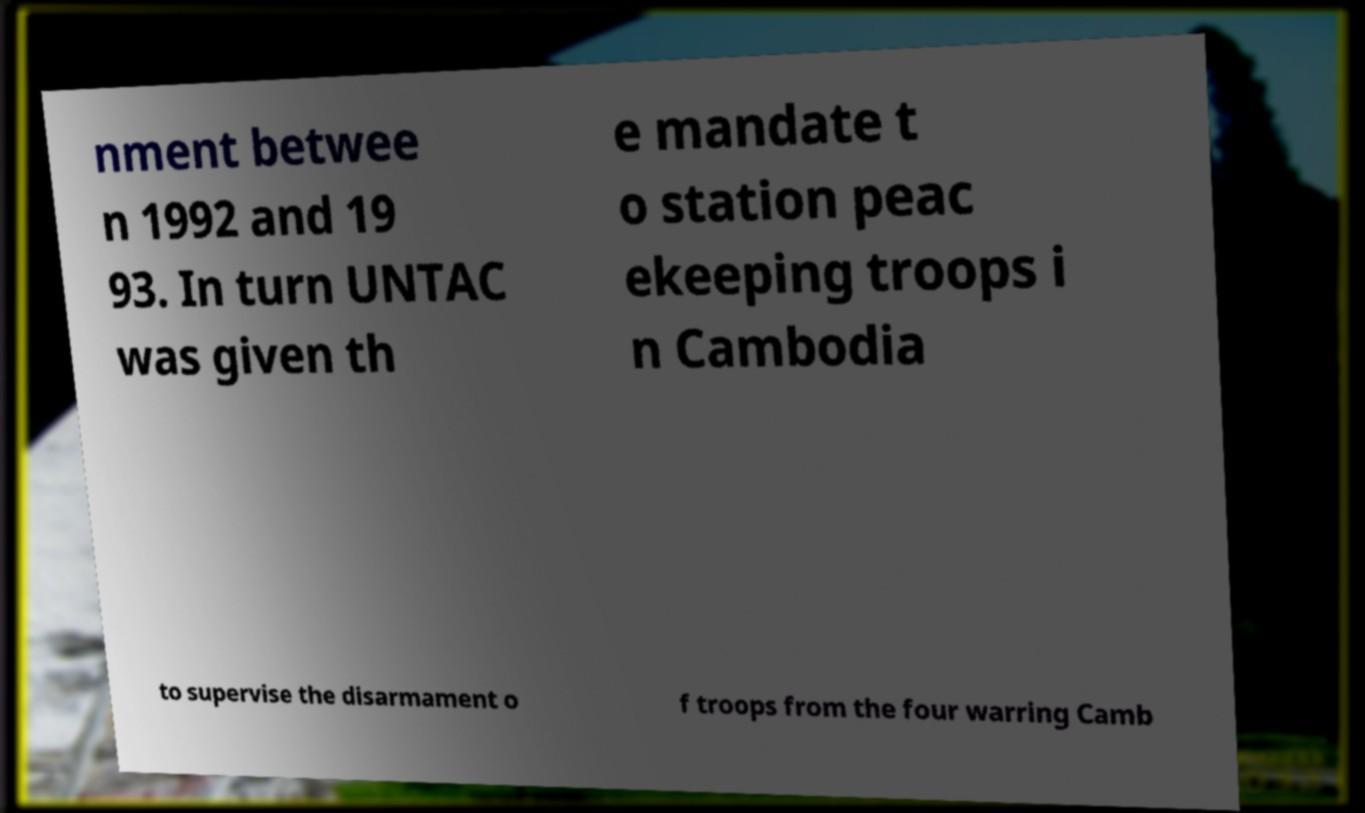I need the written content from this picture converted into text. Can you do that? nment betwee n 1992 and 19 93. In turn UNTAC was given th e mandate t o station peac ekeeping troops i n Cambodia to supervise the disarmament o f troops from the four warring Camb 